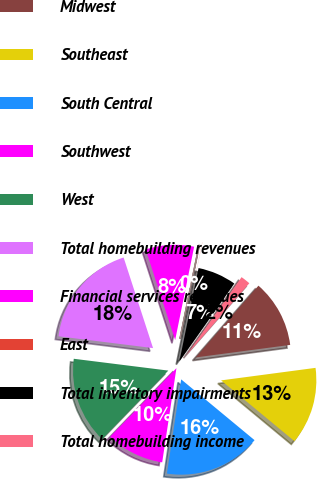Convert chart. <chart><loc_0><loc_0><loc_500><loc_500><pie_chart><fcel>Midwest<fcel>Southeast<fcel>South Central<fcel>Southwest<fcel>West<fcel>Total homebuilding revenues<fcel>Financial services revenues<fcel>East<fcel>Total inventory impairments<fcel>Total homebuilding income<nl><fcel>11.47%<fcel>13.11%<fcel>16.38%<fcel>9.84%<fcel>14.75%<fcel>18.02%<fcel>8.2%<fcel>0.02%<fcel>6.56%<fcel>1.65%<nl></chart> 